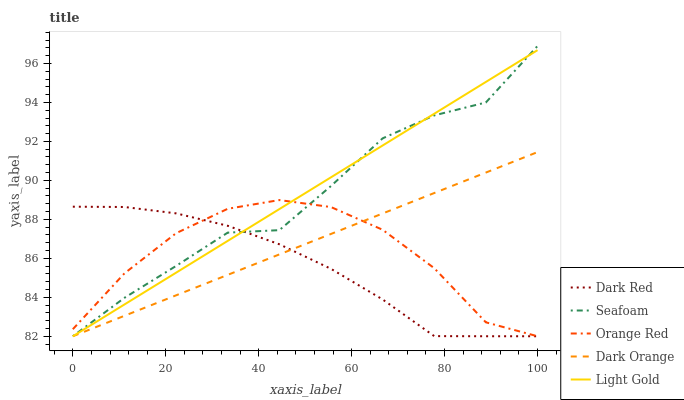Does Dark Red have the minimum area under the curve?
Answer yes or no. Yes. Does Light Gold have the maximum area under the curve?
Answer yes or no. Yes. Does Light Gold have the minimum area under the curve?
Answer yes or no. No. Does Dark Red have the maximum area under the curve?
Answer yes or no. No. Is Light Gold the smoothest?
Answer yes or no. Yes. Is Seafoam the roughest?
Answer yes or no. Yes. Is Dark Red the smoothest?
Answer yes or no. No. Is Dark Red the roughest?
Answer yes or no. No. Does Dark Orange have the lowest value?
Answer yes or no. Yes. Does Seafoam have the highest value?
Answer yes or no. Yes. Does Light Gold have the highest value?
Answer yes or no. No. Does Seafoam intersect Dark Red?
Answer yes or no. Yes. Is Seafoam less than Dark Red?
Answer yes or no. No. Is Seafoam greater than Dark Red?
Answer yes or no. No. 